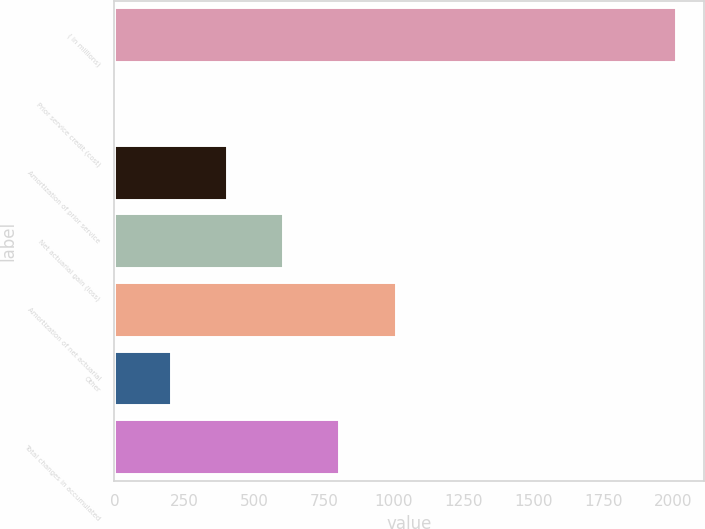Convert chart to OTSL. <chart><loc_0><loc_0><loc_500><loc_500><bar_chart><fcel>( in millions)<fcel>Prior service credit (cost)<fcel>Amortization of prior service<fcel>Net actuarial gain (loss)<fcel>Amortization of net actuarial<fcel>Other<fcel>Total changes in accumulated<nl><fcel>2010<fcel>1.84<fcel>403.48<fcel>604.3<fcel>1005.94<fcel>202.66<fcel>805.12<nl></chart> 